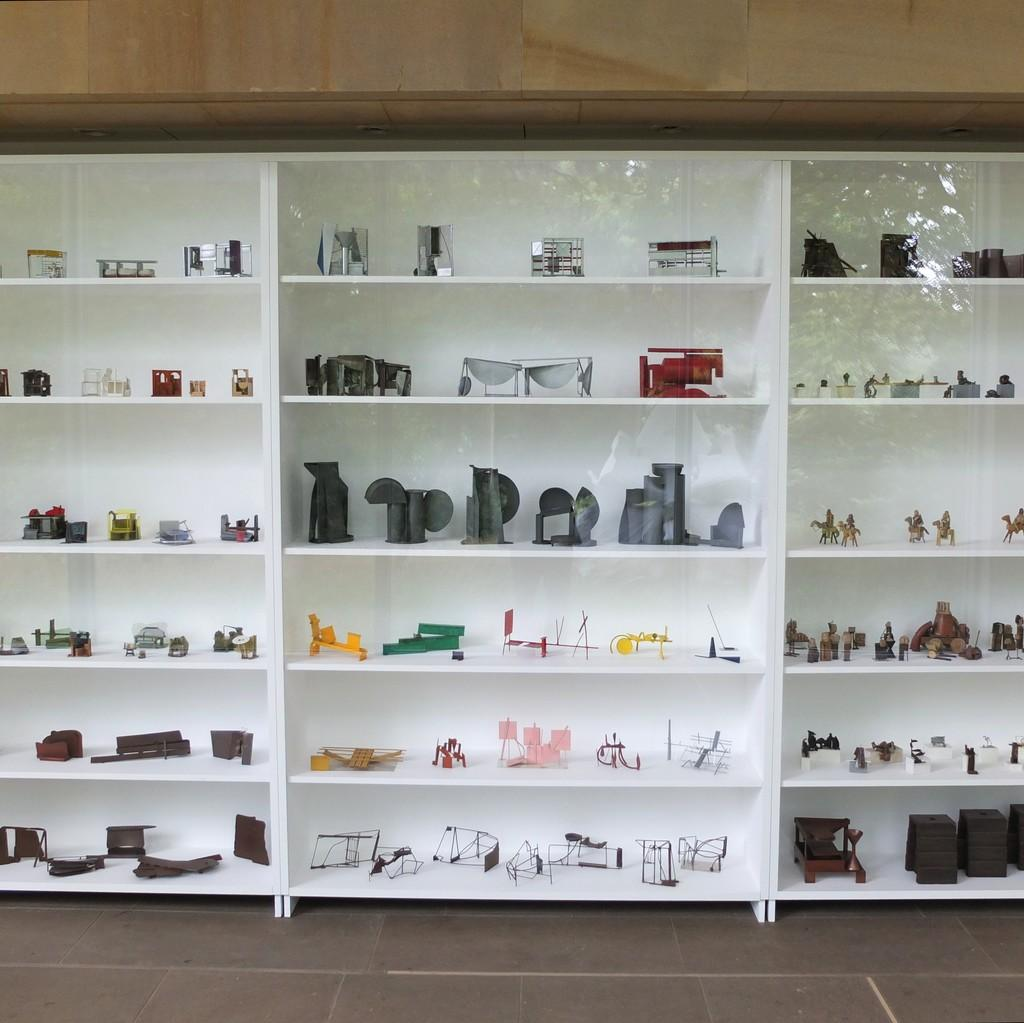What is the primary surface visible in the image? There is a floor in the image. What object is placed on the floor? There is a rack on the floor. What is the color of the rack and floor? The rack and floor are white in color. What is filling the cracks in the floor? The cracks in the floor are filled with crafts. What is placed on top of the rack? There is a wooden frame on top of the rack. How many prisoners are visible in the image? There are no prisoners or jail in the image; it features a white floor with a rack and crafts. What is the price of the wooden frame in the image? There is no price mentioned or visible in the image; it only shows a wooden frame on top of the rack. 